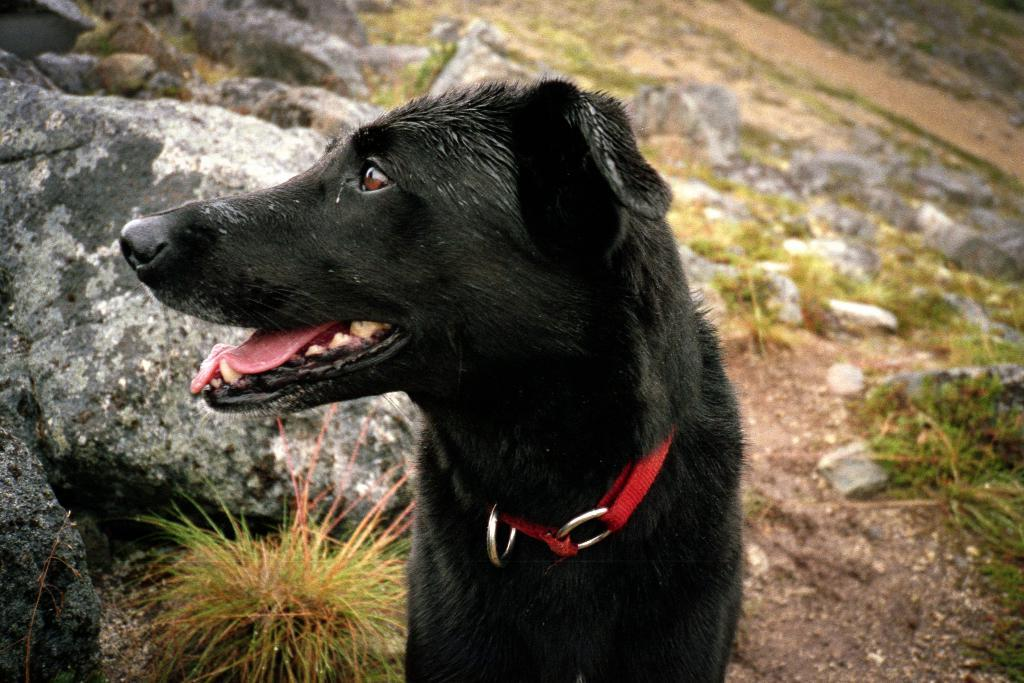What type of animal is in the image? There is a black dog in the image. What can be seen in the background of the image? There are stones and grass in the background of the image. How many trucks are visible in the image? There are no trucks present in the image. What is the size of the van in the image? There is no van present in the image. 